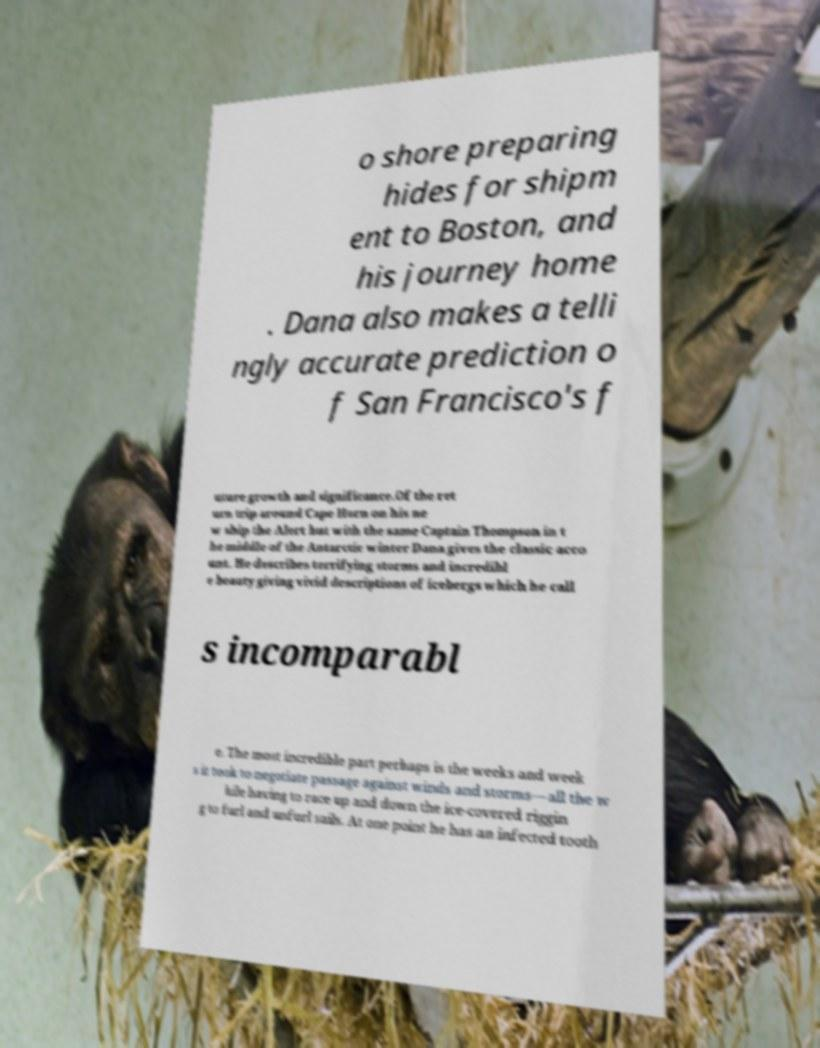For documentation purposes, I need the text within this image transcribed. Could you provide that? o shore preparing hides for shipm ent to Boston, and his journey home . Dana also makes a telli ngly accurate prediction o f San Francisco's f uture growth and significance.Of the ret urn trip around Cape Horn on his ne w ship the Alert but with the same Captain Thompson in t he middle of the Antarctic winter Dana gives the classic acco unt. He describes terrifying storms and incredibl e beauty giving vivid descriptions of icebergs which he call s incomparabl e. The most incredible part perhaps is the weeks and week s it took to negotiate passage against winds and storms—all the w hile having to race up and down the ice-covered riggin g to furl and unfurl sails. At one point he has an infected tooth 